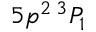<formula> <loc_0><loc_0><loc_500><loc_500>5 p ^ { 2 } \, ^ { 3 } P _ { 1 }</formula> 